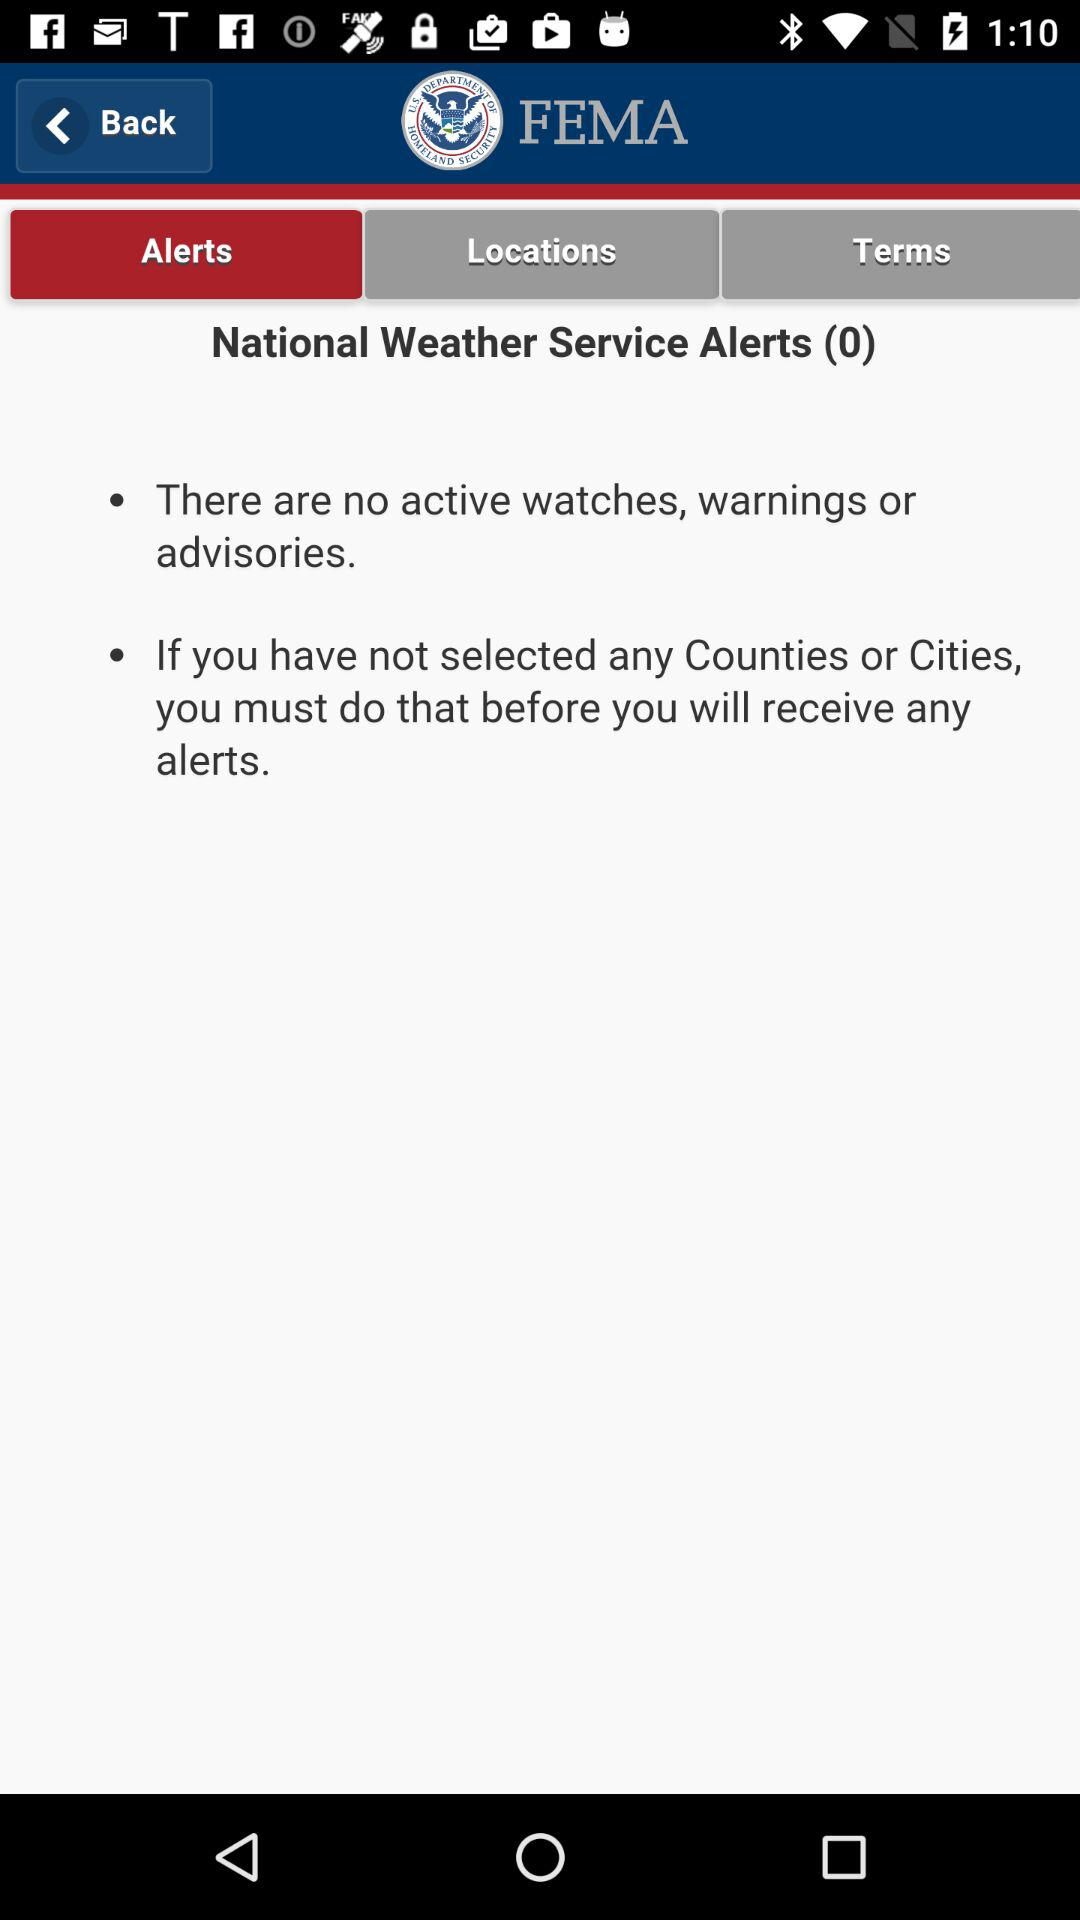Which tab is selected? The selected tab is "Alerts". 